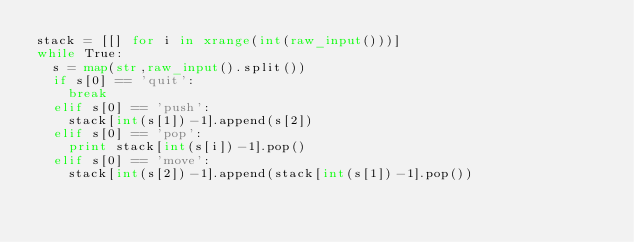Convert code to text. <code><loc_0><loc_0><loc_500><loc_500><_Python_>stack = [[] for i in xrange(int(raw_input()))]
while True:
	s = map(str,raw_input().split())
	if s[0] == 'quit':
		break
	elif s[0] == 'push':
		stack[int(s[1])-1].append(s[2])
	elif s[0] == 'pop':
		print stack[int(s[i])-1].pop()
	elif s[0] == 'move':
		stack[int(s[2])-1].append(stack[int(s[1])-1].pop())</code> 